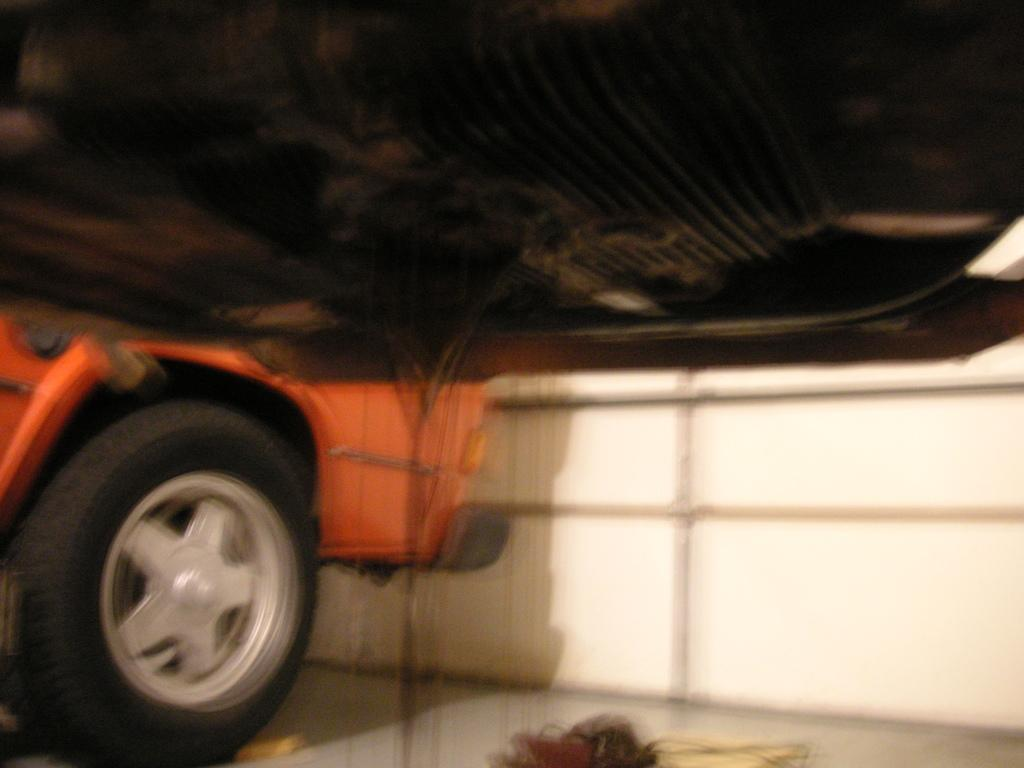What vehicle is located on the left side of the image? There is a car on the left side of the image. What can be seen at the top of the image? There is an object at the top of the image. What type of structure is visible in the background of the image? There is a wall visible in the background of the image. Can you tell me how many fish are swimming in the lake in the image? There is no lake present in the image, so it is not possible to determine the number of fish swimming in it. 